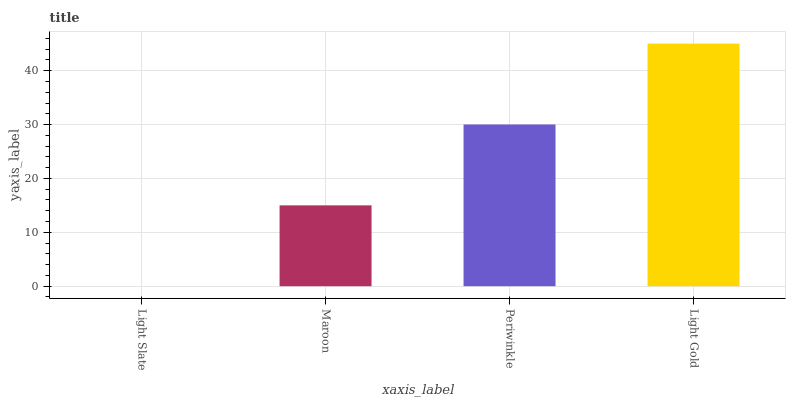Is Light Slate the minimum?
Answer yes or no. Yes. Is Light Gold the maximum?
Answer yes or no. Yes. Is Maroon the minimum?
Answer yes or no. No. Is Maroon the maximum?
Answer yes or no. No. Is Maroon greater than Light Slate?
Answer yes or no. Yes. Is Light Slate less than Maroon?
Answer yes or no. Yes. Is Light Slate greater than Maroon?
Answer yes or no. No. Is Maroon less than Light Slate?
Answer yes or no. No. Is Periwinkle the high median?
Answer yes or no. Yes. Is Maroon the low median?
Answer yes or no. Yes. Is Light Gold the high median?
Answer yes or no. No. Is Periwinkle the low median?
Answer yes or no. No. 